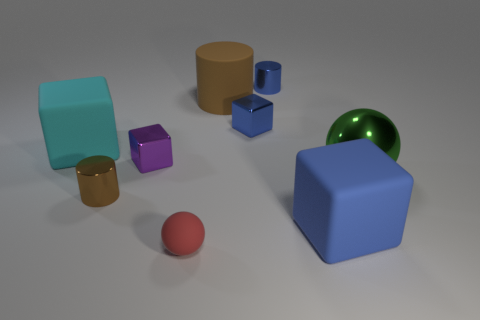Subtract all small shiny cylinders. How many cylinders are left? 1 Subtract all brown cylinders. How many blue blocks are left? 2 Subtract all blue cylinders. How many cylinders are left? 2 Subtract all cylinders. How many objects are left? 6 Add 4 large green metal spheres. How many large green metal spheres are left? 5 Add 7 tiny blue metallic cylinders. How many tiny blue metallic cylinders exist? 8 Subtract 0 red cylinders. How many objects are left? 9 Subtract 3 cylinders. How many cylinders are left? 0 Subtract all green blocks. Subtract all gray cylinders. How many blocks are left? 4 Subtract all yellow spheres. Subtract all big matte cylinders. How many objects are left? 8 